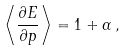Convert formula to latex. <formula><loc_0><loc_0><loc_500><loc_500>\left \langle \frac { \partial E } { \partial p } \right \rangle = 1 + \alpha \, ,</formula> 